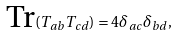Convert formula to latex. <formula><loc_0><loc_0><loc_500><loc_500>\text {Tr} ( T _ { a b } T _ { c d } ) = 4 \delta _ { a c } \delta _ { b d } ,</formula> 